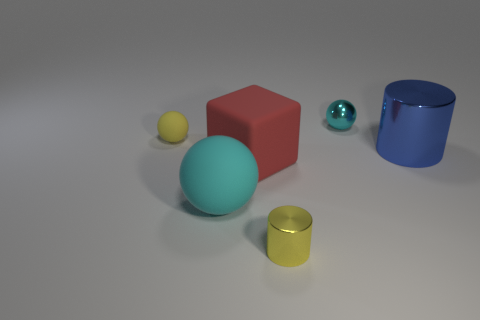What is the color of the matte thing that is the same size as the red matte block?
Your answer should be compact. Cyan. Is there a big cyan matte thing that is right of the tiny cyan thing that is behind the yellow ball?
Ensure brevity in your answer.  No. What is the material of the yellow object on the right side of the large cyan matte object?
Offer a terse response. Metal. Do the big thing that is on the right side of the big red cube and the cyan object that is left of the red rubber object have the same material?
Make the answer very short. No. Are there an equal number of red rubber blocks behind the large blue metal cylinder and yellow objects behind the yellow sphere?
Your answer should be compact. Yes. How many tiny brown spheres are the same material as the red block?
Offer a terse response. 0. What shape is the big matte object that is the same color as the metal ball?
Provide a short and direct response. Sphere. There is a metal cylinder in front of the cylinder that is on the right side of the metallic ball; what size is it?
Ensure brevity in your answer.  Small. There is a tiny yellow thing that is in front of the blue object; is its shape the same as the tiny yellow object behind the blue metal object?
Offer a very short reply. No. Is the number of cubes that are to the right of the tiny metal cylinder the same as the number of large blue metallic objects?
Offer a very short reply. No. 